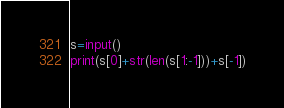Convert code to text. <code><loc_0><loc_0><loc_500><loc_500><_Python_>s=input()
print(s[0]+str(len(s[1:-1]))+s[-1])
</code> 